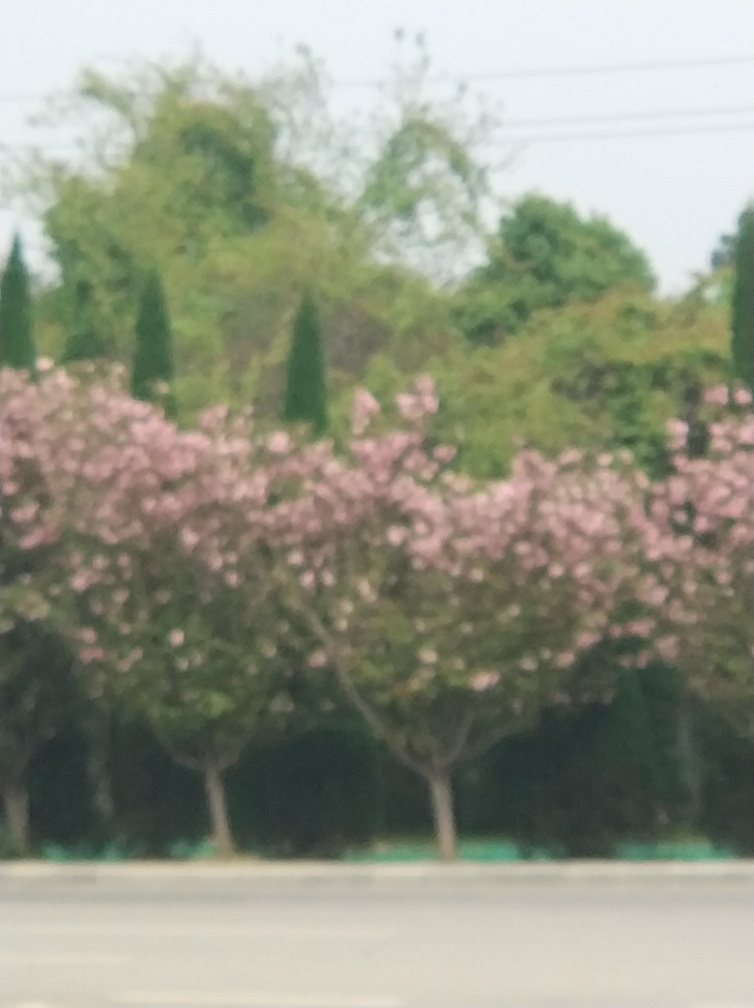Is this image suitable for use in a professional setting, like a brochure or website? This particular image is not ideally suited for professional use due to its lack of sharpness and focus. For a brochure or website, a crisp and clear image would be more effective in conveying quality and attention to detail. 